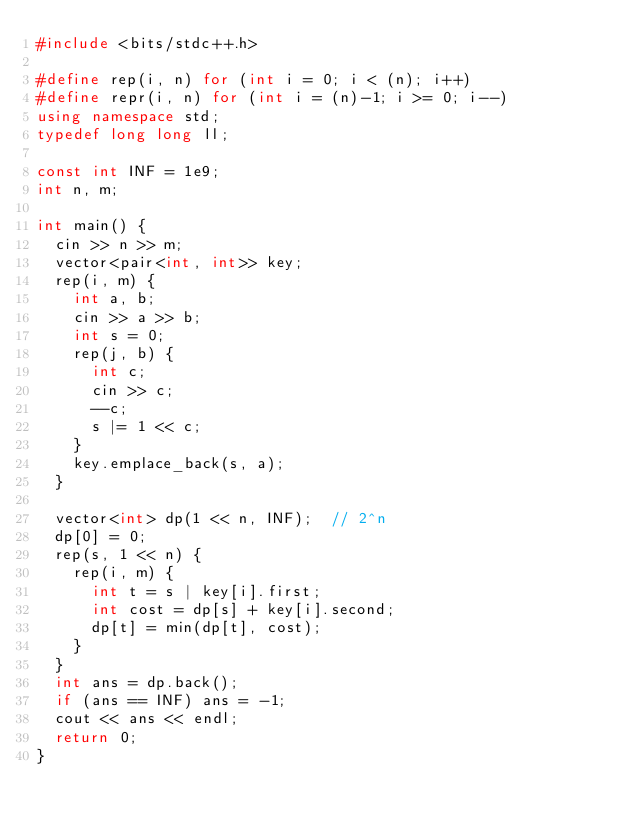<code> <loc_0><loc_0><loc_500><loc_500><_C++_>#include <bits/stdc++.h>

#define rep(i, n) for (int i = 0; i < (n); i++)
#define repr(i, n) for (int i = (n)-1; i >= 0; i--)
using namespace std;
typedef long long ll;

const int INF = 1e9;
int n, m;

int main() {
  cin >> n >> m;
  vector<pair<int, int>> key;
  rep(i, m) {
    int a, b;
    cin >> a >> b;
    int s = 0;
    rep(j, b) {
      int c;
      cin >> c;
      --c;
      s |= 1 << c;
    }
    key.emplace_back(s, a);
  }

  vector<int> dp(1 << n, INF);  // 2^n
  dp[0] = 0;
  rep(s, 1 << n) {
    rep(i, m) {
      int t = s | key[i].first;
      int cost = dp[s] + key[i].second;
      dp[t] = min(dp[t], cost);
    }
  }
  int ans = dp.back();
  if (ans == INF) ans = -1;
  cout << ans << endl;
  return 0;
}
</code> 